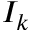<formula> <loc_0><loc_0><loc_500><loc_500>I _ { k }</formula> 